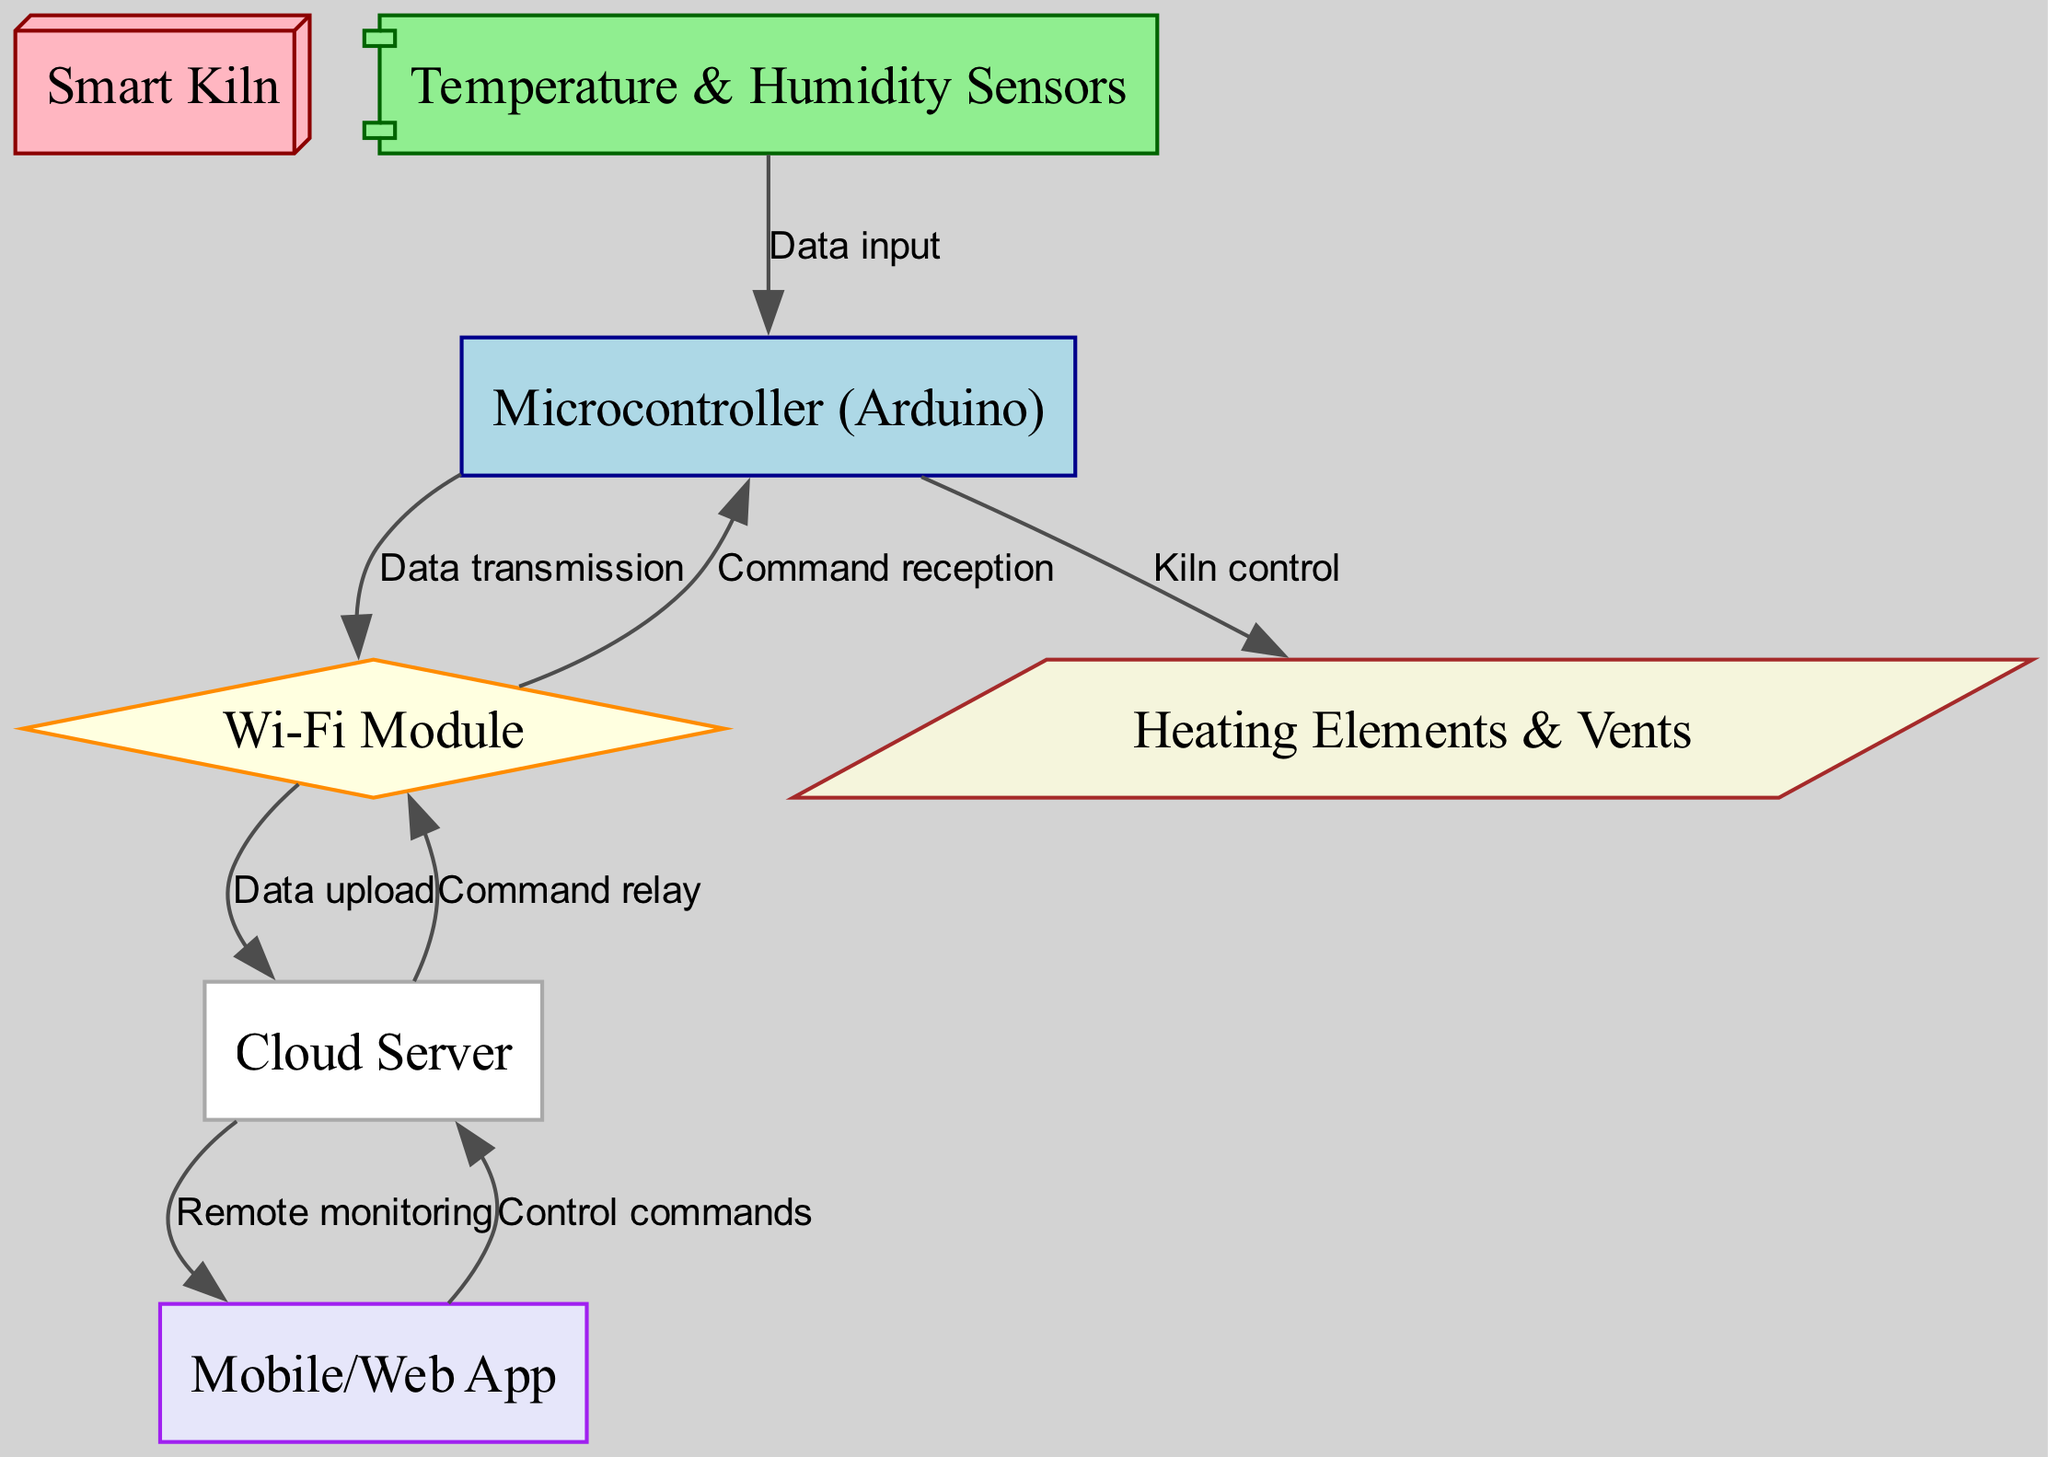What are the two types of sensors in the diagram? The diagram includes "Temperature" and "Humidity" as part of the label for the "Temperature & Humidity Sensors" node.
Answer: Temperature & Humidity How many nodes are present in the diagram? The diagram lists 7 distinct nodes: Smart Kiln, Temperature & Humidity Sensors, Microcontroller, Wi-Fi Module, Cloud Server, Mobile/Web App, and Heating Elements & Vents.
Answer: 7 What is the direction of data flow from the sensors to the controller? The arrow from "Temperature & Humidity Sensors" to "Microcontroller (Arduino)" indicates that data flows from the sensors towards the controller.
Answer: Data input Which component is responsible for receiving commands? The "Microcontroller (Arduino)" node is where commands are received as indicated by the directed edge labeled "Command reception" from the Wi-Fi Module, leading to the controller.
Answer: Microcontroller What kind of commands does the mobile/web app send? The "Mobile/Web App" node sends "Control commands" to the "Cloud Server" based on the edge labeled "Control commands."
Answer: Control commands Which components interact directly with the actuators? The "Microcontroller (Arduino)" node interacts directly with the "Heating Elements & Vents," providing control as indicated by the edge labeled "Kiln control."
Answer: Microcontroller How does data initially enter the system? Data initially enters through the "Temperature & Humidity Sensors," which is the first node in the diagram indicating input.
Answer: Data input What type of communication is established between the Wi-Fi module and the cloud server? The communication establishes "Data upload" from the Wi-Fi Module to the Cloud Server, as shown in the edge labeled "Data upload."
Answer: Data upload 